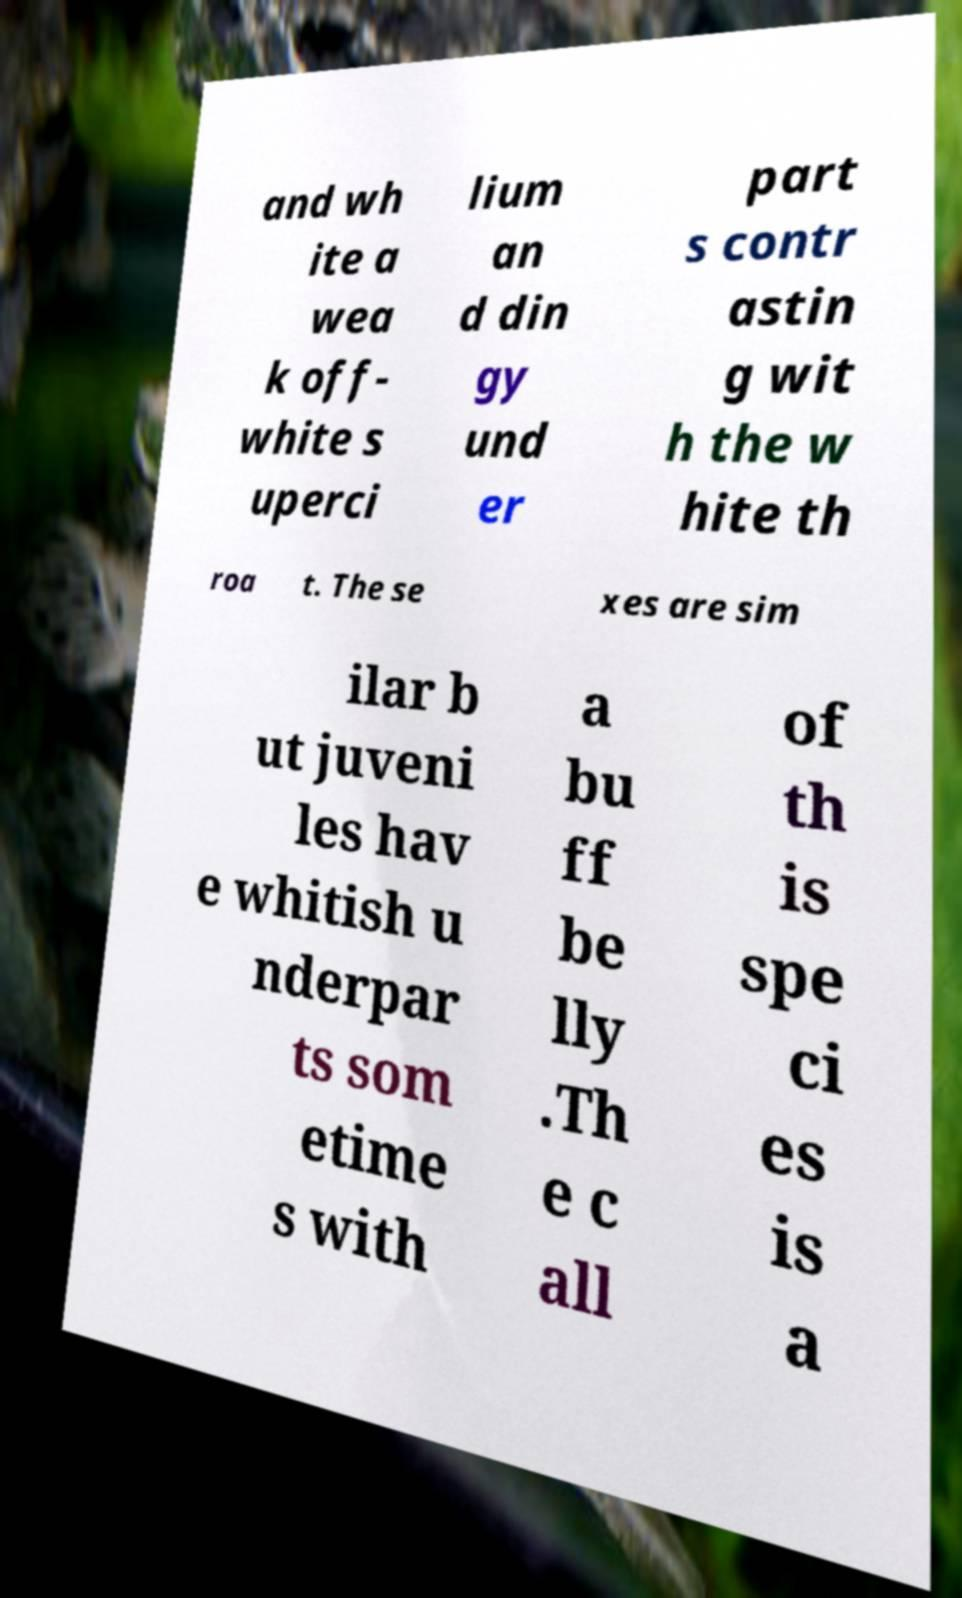Can you accurately transcribe the text from the provided image for me? and wh ite a wea k off- white s uperci lium an d din gy und er part s contr astin g wit h the w hite th roa t. The se xes are sim ilar b ut juveni les hav e whitish u nderpar ts som etime s with a bu ff be lly .Th e c all of th is spe ci es is a 